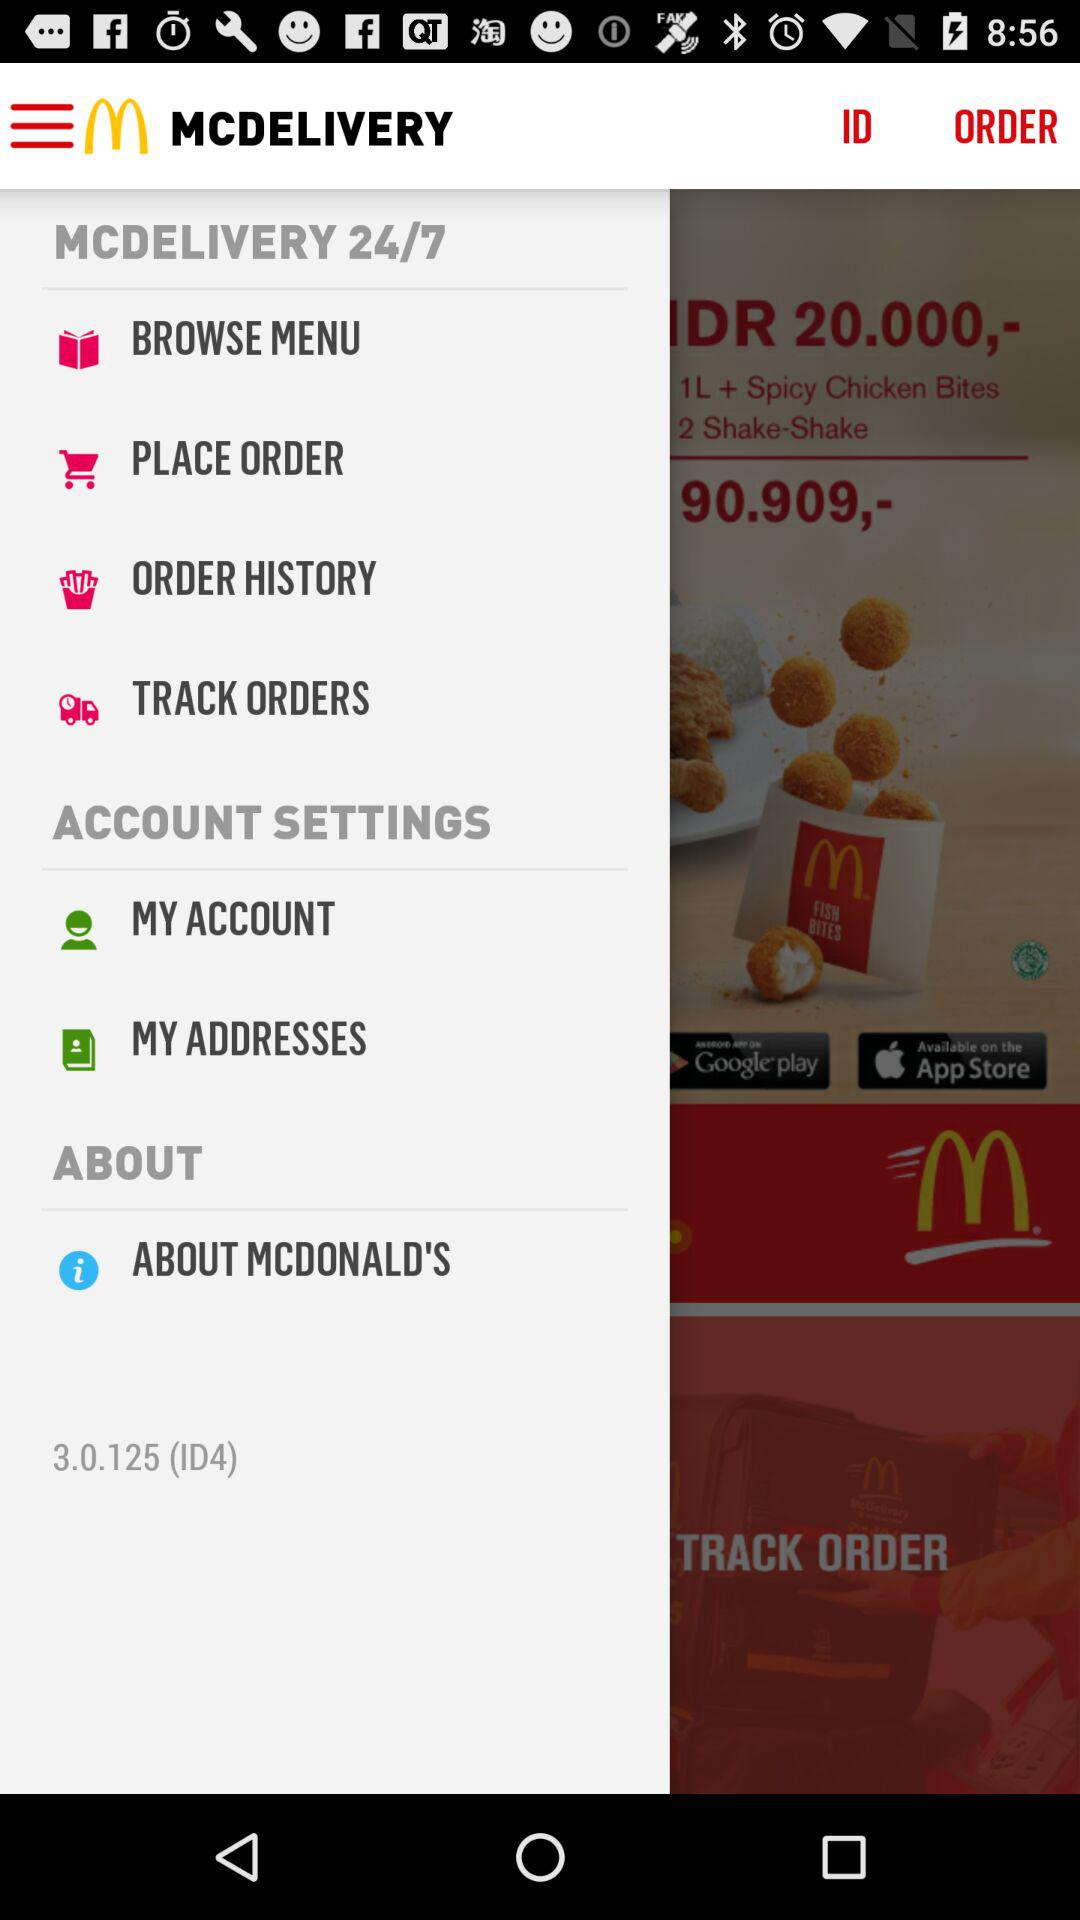What is the version of the application? The version of the application is 3.0.125 (ID4). 